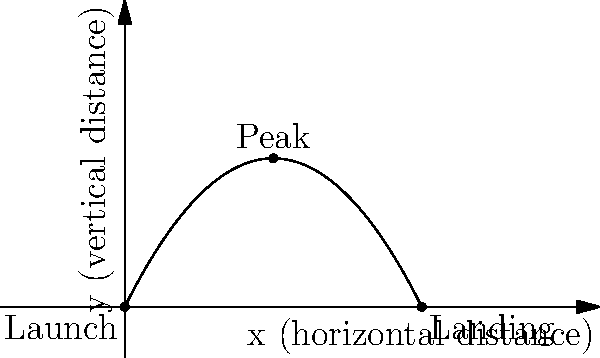In a critically acclaimed science fiction film, a futuristic projectile is launched from ground level and follows a parabolic trajectory. The arc of its path is represented by the equation $y = -0.25x^2 + 2x$, where $x$ and $y$ are measured in kilometers. At what horizontal distance from the launch point does the projectile reach its maximum height? How might this trajectory symbolize the narrative arc of the film, considering Fredric Jameson's notion of cognitive mapping in science fiction? To find the horizontal distance at which the projectile reaches its maximum height, we need to follow these steps:

1) The general equation for a parabola is $y = ax^2 + bx + c$. In this case, we have $y = -0.25x^2 + 2x$.

2) The maximum point of a parabola occurs at the axis of symmetry. For a parabola in the form $y = ax^2 + bx + c$, the x-coordinate of the axis of symmetry is given by $x = -\frac{b}{2a}$.

3) In our equation, $a = -0.25$ and $b = 2$. Let's substitute these values:

   $x = -\frac{2}{2(-0.25)} = -\frac{2}{-0.5} = 4$

4) Therefore, the projectile reaches its maximum height at a horizontal distance of 4 kilometers from the launch point.

From a film criticism perspective, drawing on Fredric Jameson's ideas:

5) The parabolic trajectory can be seen as a metaphor for the narrative arc of the film. The rise and fall of the projectile might mirror the plot's development, climax, and resolution.

6) Jameson's concept of cognitive mapping in science fiction suggests that such narratives help us understand and navigate complex social realities. The precise mathematical description of the projectile's path could symbolize an attempt to make sense of an otherwise incomprehensible future world.

7) The peak of the trajectory at exactly 4 km might represent a critical turning point in the film's narrative, perhaps a moment of realization or a key event that changes the course of the story.
Answer: 4 kilometers 